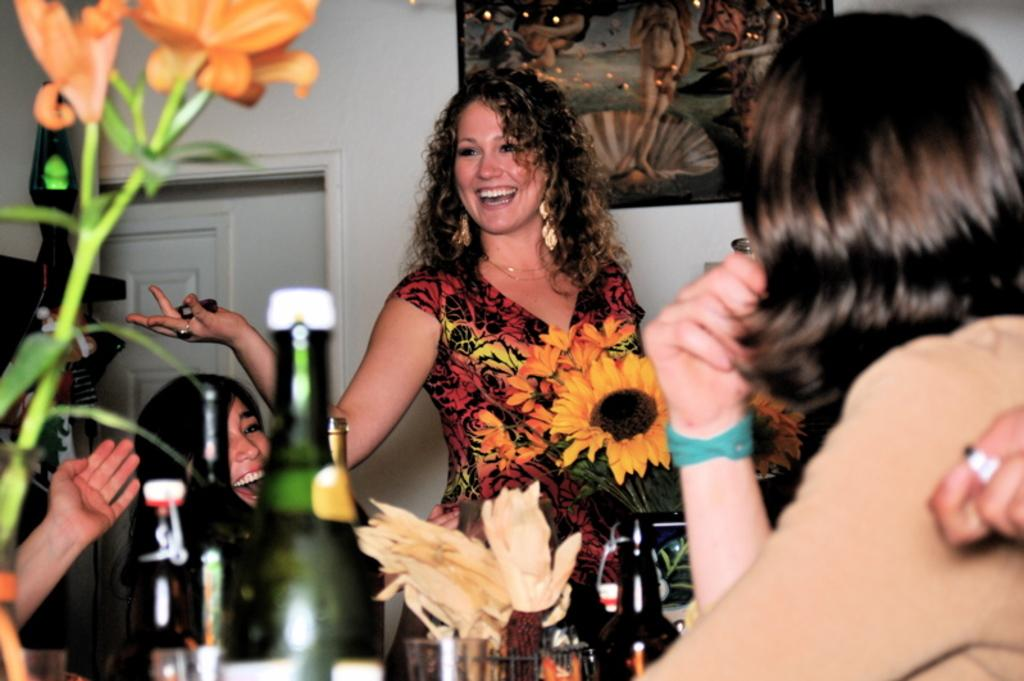How many women are in the image? There are three women in the image. What is the facial expression of the women? The women are smiling. What objects can be seen in the image besides the women? There are bottles and flower vases in the image. What architectural features can be seen in the background of the image? There is a wall, a door, and a frame in the background of the image. What nation are the women protesting against in the image? There is no protest or reference to a nation in the image; the women are simply smiling. Who is the expert in the image? There is no expert present in the image; it features three women smiling and other objects. 